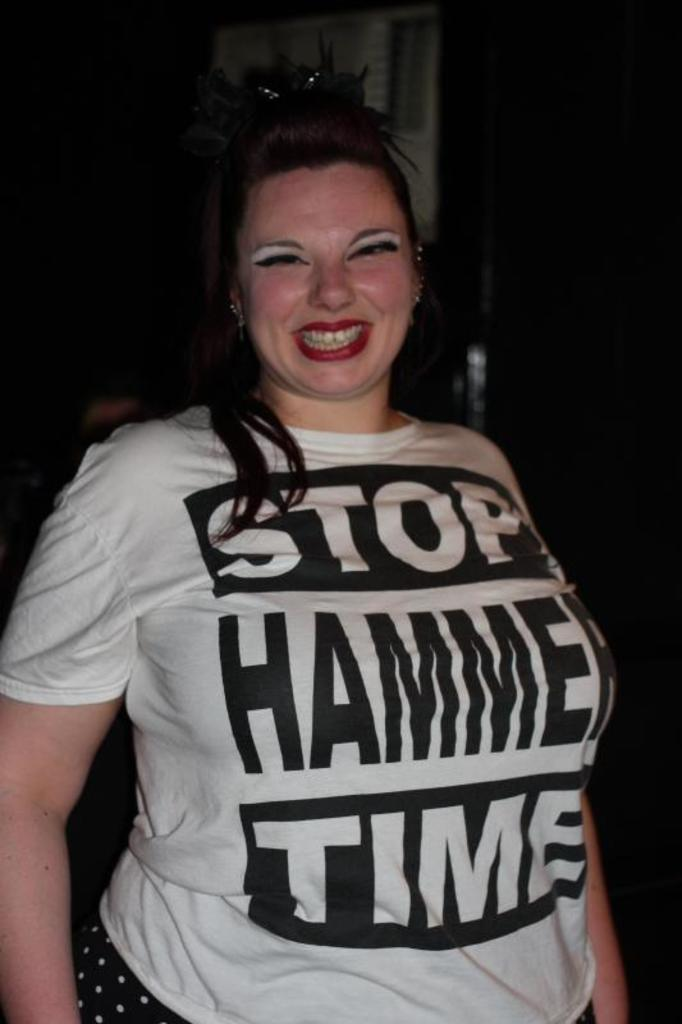Who is present in the image? There is a woman in the image. What expression does the woman have? The woman is smiling. What can be seen in the background of the image? The background of the image is dark. What type of idea can be seen floating in the ocean in the image? There is no ocean or idea present in the image; it features a woman with a dark background. What kind of music is the band playing in the background of the image? There is no band or music present in the image; it features a woman with a dark background. 